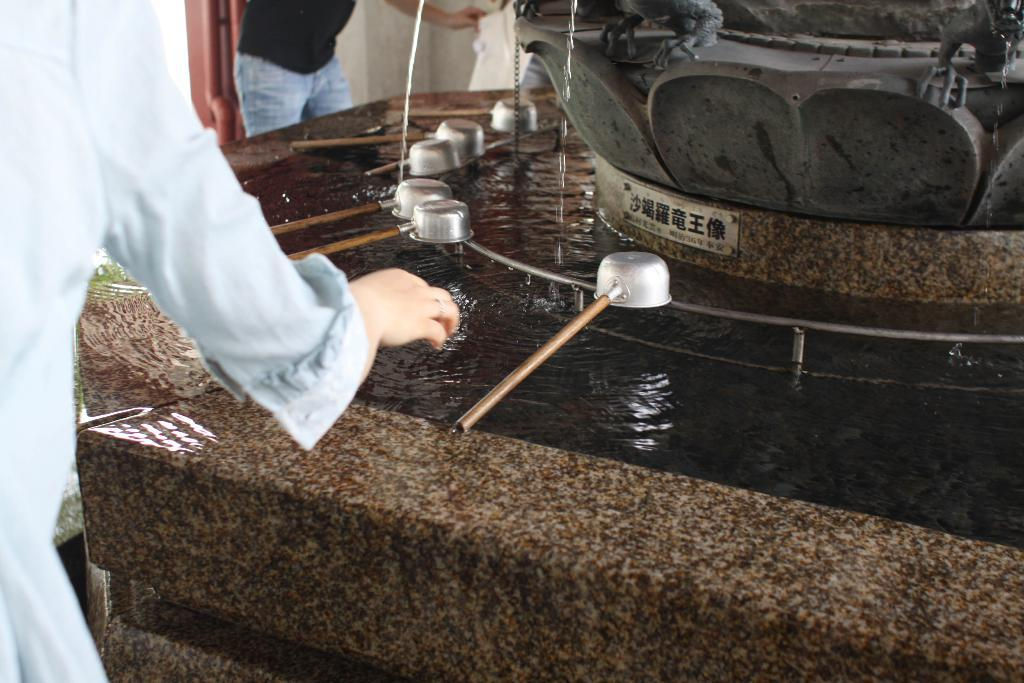How many people are present in the image? There are two persons in the image. What is visible in the background of the image? There is water visible in the image. What objects can be used for eating or cooking in the image? There are utensils in the image. What is the shape of the object on the right side of the image? The object on the right side of the image is flower-shaped. What is written on the flower-shaped object? There is something written on the flower-shaped object. What type of straw is being used to drink from the water in the image? There is no straw visible in the image; it features two persons, utensils, and a flower-shaped object with writing. Can you see a crook in the image? There is no crook present in the image. 